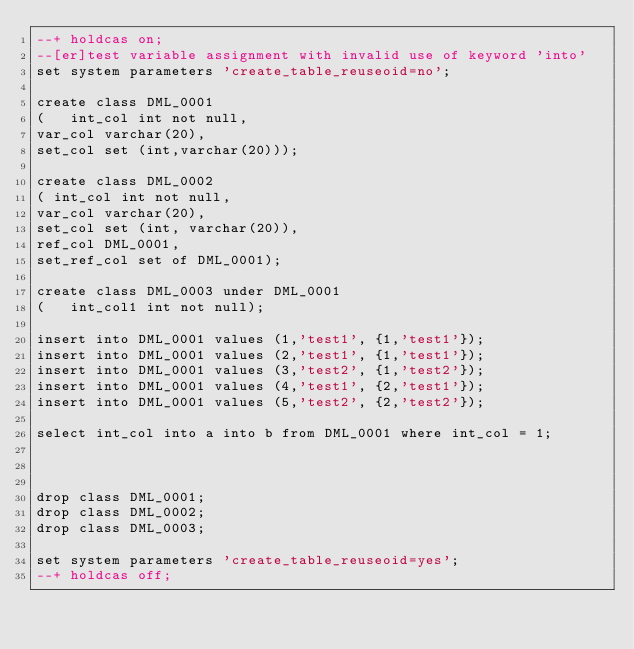Convert code to text. <code><loc_0><loc_0><loc_500><loc_500><_SQL_>--+ holdcas on;
--[er]test variable assignment with invalid use of keyword 'into'
set system parameters 'create_table_reuseoid=no';

create class DML_0001
( 	int_col int not null,
var_col varchar(20),
set_col set (int,varchar(20)));

create class DML_0002 	
(	int_col int not null,
var_col varchar(20),
set_col set (int, varchar(20)),
ref_col DML_0001,
set_ref_col set of DML_0001);

create class DML_0003 under DML_0001
( 	int_col1 int not null);

insert into DML_0001 values (1,'test1', {1,'test1'});
insert into DML_0001 values (2,'test1', {1,'test1'});
insert into DML_0001 values (3,'test2', {1,'test2'});
insert into DML_0001 values (4,'test1', {2,'test1'});
insert into DML_0001 values (5,'test2', {2,'test2'});

select int_col into a into b from DML_0001 where int_col = 1;



drop class DML_0001;
drop class DML_0002;
drop class DML_0003;

set system parameters 'create_table_reuseoid=yes';
--+ holdcas off;
</code> 